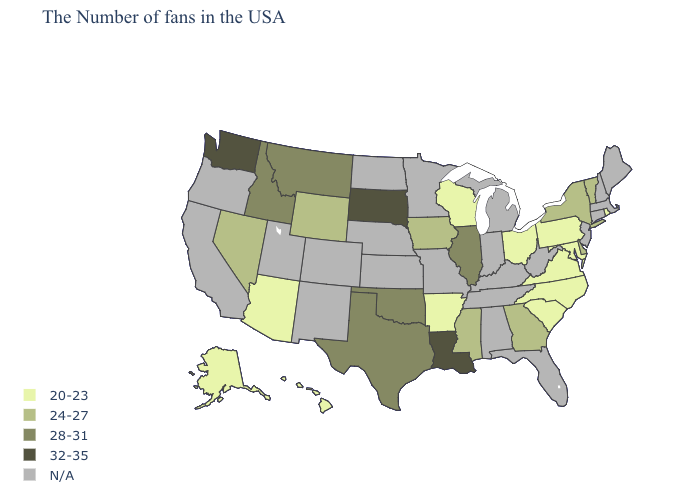Which states have the lowest value in the USA?
Answer briefly. Rhode Island, Maryland, Pennsylvania, Virginia, North Carolina, South Carolina, Ohio, Wisconsin, Arkansas, Arizona, Alaska, Hawaii. What is the value of Hawaii?
Keep it brief. 20-23. Name the states that have a value in the range 32-35?
Give a very brief answer. Louisiana, South Dakota, Washington. Does the first symbol in the legend represent the smallest category?
Write a very short answer. Yes. Name the states that have a value in the range 24-27?
Write a very short answer. Vermont, New York, Delaware, Georgia, Mississippi, Iowa, Wyoming, Nevada. Does Pennsylvania have the lowest value in the Northeast?
Give a very brief answer. Yes. Name the states that have a value in the range 28-31?
Keep it brief. Illinois, Oklahoma, Texas, Montana, Idaho. Does Rhode Island have the highest value in the Northeast?
Quick response, please. No. Which states have the lowest value in the USA?
Give a very brief answer. Rhode Island, Maryland, Pennsylvania, Virginia, North Carolina, South Carolina, Ohio, Wisconsin, Arkansas, Arizona, Alaska, Hawaii. Which states have the lowest value in the USA?
Write a very short answer. Rhode Island, Maryland, Pennsylvania, Virginia, North Carolina, South Carolina, Ohio, Wisconsin, Arkansas, Arizona, Alaska, Hawaii. Does the first symbol in the legend represent the smallest category?
Write a very short answer. Yes. What is the value of Alabama?
Quick response, please. N/A. Name the states that have a value in the range N/A?
Write a very short answer. Maine, Massachusetts, New Hampshire, Connecticut, New Jersey, West Virginia, Florida, Michigan, Kentucky, Indiana, Alabama, Tennessee, Missouri, Minnesota, Kansas, Nebraska, North Dakota, Colorado, New Mexico, Utah, California, Oregon. 